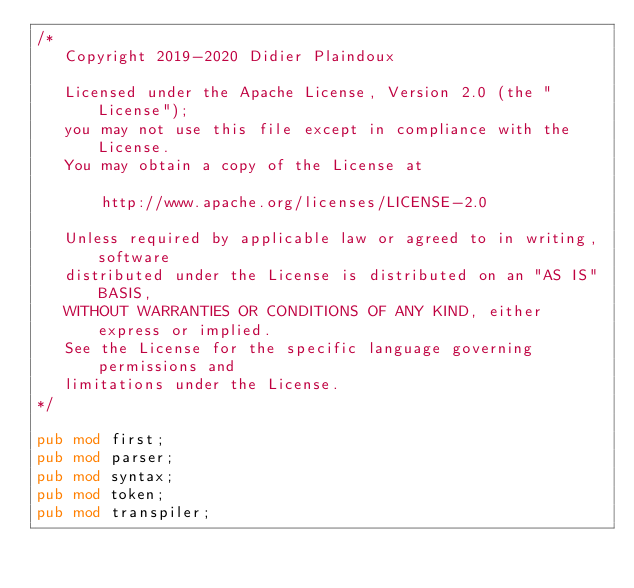<code> <loc_0><loc_0><loc_500><loc_500><_Rust_>/*
   Copyright 2019-2020 Didier Plaindoux

   Licensed under the Apache License, Version 2.0 (the "License");
   you may not use this file except in compliance with the License.
   You may obtain a copy of the License at

       http://www.apache.org/licenses/LICENSE-2.0

   Unless required by applicable law or agreed to in writing, software
   distributed under the License is distributed on an "AS IS" BASIS,
   WITHOUT WARRANTIES OR CONDITIONS OF ANY KIND, either express or implied.
   See the License for the specific language governing permissions and
   limitations under the License.
*/

pub mod first;
pub mod parser;
pub mod syntax;
pub mod token;
pub mod transpiler;
</code> 